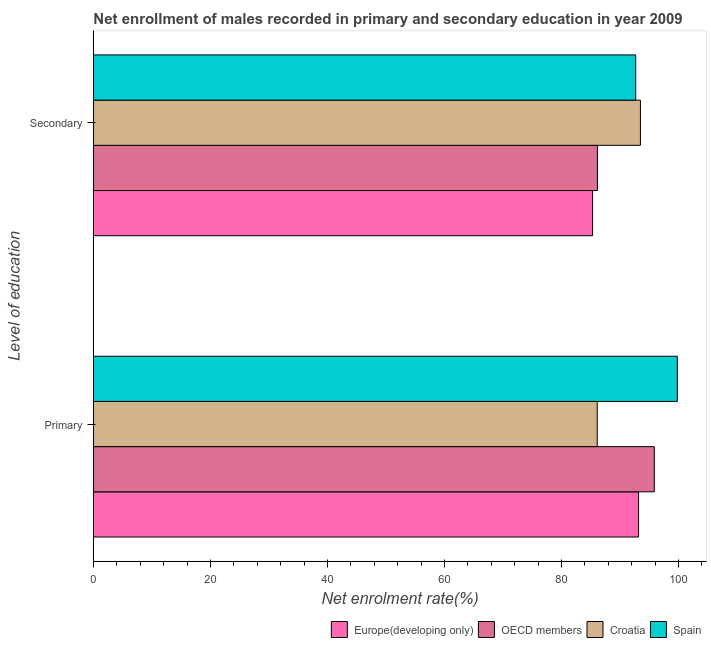How many different coloured bars are there?
Make the answer very short. 4. Are the number of bars per tick equal to the number of legend labels?
Offer a very short reply. Yes. Are the number of bars on each tick of the Y-axis equal?
Provide a succinct answer. Yes. How many bars are there on the 1st tick from the bottom?
Make the answer very short. 4. What is the label of the 1st group of bars from the top?
Give a very brief answer. Secondary. What is the enrollment rate in secondary education in OECD members?
Offer a terse response. 86.14. Across all countries, what is the maximum enrollment rate in primary education?
Ensure brevity in your answer.  99.8. Across all countries, what is the minimum enrollment rate in primary education?
Your answer should be very brief. 86.11. In which country was the enrollment rate in primary education maximum?
Your answer should be compact. Spain. In which country was the enrollment rate in primary education minimum?
Offer a very short reply. Croatia. What is the total enrollment rate in primary education in the graph?
Your response must be concise. 374.94. What is the difference between the enrollment rate in primary education in Spain and that in OECD members?
Give a very brief answer. 3.93. What is the difference between the enrollment rate in primary education in Spain and the enrollment rate in secondary education in Europe(developing only)?
Give a very brief answer. 14.48. What is the average enrollment rate in secondary education per country?
Provide a short and direct response. 89.41. What is the difference between the enrollment rate in secondary education and enrollment rate in primary education in Croatia?
Provide a succinct answer. 7.38. What is the ratio of the enrollment rate in primary education in OECD members to that in Croatia?
Your answer should be very brief. 1.11. Is the enrollment rate in secondary education in Croatia less than that in Europe(developing only)?
Offer a very short reply. No. What does the 4th bar from the bottom in Primary represents?
Your answer should be compact. Spain. How many bars are there?
Your answer should be compact. 8. How many countries are there in the graph?
Your answer should be very brief. 4. Are the values on the major ticks of X-axis written in scientific E-notation?
Keep it short and to the point. No. Does the graph contain grids?
Offer a terse response. No. Where does the legend appear in the graph?
Give a very brief answer. Bottom right. How are the legend labels stacked?
Offer a terse response. Horizontal. What is the title of the graph?
Your response must be concise. Net enrollment of males recorded in primary and secondary education in year 2009. Does "Macao" appear as one of the legend labels in the graph?
Provide a succinct answer. No. What is the label or title of the X-axis?
Your answer should be very brief. Net enrolment rate(%). What is the label or title of the Y-axis?
Make the answer very short. Level of education. What is the Net enrolment rate(%) in Europe(developing only) in Primary?
Ensure brevity in your answer.  93.17. What is the Net enrolment rate(%) in OECD members in Primary?
Make the answer very short. 95.86. What is the Net enrolment rate(%) of Croatia in Primary?
Ensure brevity in your answer.  86.11. What is the Net enrolment rate(%) of Spain in Primary?
Ensure brevity in your answer.  99.8. What is the Net enrolment rate(%) of Europe(developing only) in Secondary?
Offer a terse response. 85.31. What is the Net enrolment rate(%) of OECD members in Secondary?
Make the answer very short. 86.14. What is the Net enrolment rate(%) in Croatia in Secondary?
Offer a terse response. 93.49. What is the Net enrolment rate(%) in Spain in Secondary?
Offer a very short reply. 92.68. Across all Level of education, what is the maximum Net enrolment rate(%) of Europe(developing only)?
Your response must be concise. 93.17. Across all Level of education, what is the maximum Net enrolment rate(%) of OECD members?
Provide a succinct answer. 95.86. Across all Level of education, what is the maximum Net enrolment rate(%) of Croatia?
Make the answer very short. 93.49. Across all Level of education, what is the maximum Net enrolment rate(%) in Spain?
Your response must be concise. 99.8. Across all Level of education, what is the minimum Net enrolment rate(%) of Europe(developing only)?
Provide a short and direct response. 85.31. Across all Level of education, what is the minimum Net enrolment rate(%) in OECD members?
Keep it short and to the point. 86.14. Across all Level of education, what is the minimum Net enrolment rate(%) in Croatia?
Provide a short and direct response. 86.11. Across all Level of education, what is the minimum Net enrolment rate(%) in Spain?
Your answer should be compact. 92.68. What is the total Net enrolment rate(%) of Europe(developing only) in the graph?
Offer a very short reply. 178.49. What is the total Net enrolment rate(%) of OECD members in the graph?
Provide a succinct answer. 182.01. What is the total Net enrolment rate(%) of Croatia in the graph?
Provide a short and direct response. 179.6. What is the total Net enrolment rate(%) in Spain in the graph?
Your answer should be very brief. 192.48. What is the difference between the Net enrolment rate(%) of Europe(developing only) in Primary and that in Secondary?
Make the answer very short. 7.86. What is the difference between the Net enrolment rate(%) in OECD members in Primary and that in Secondary?
Give a very brief answer. 9.72. What is the difference between the Net enrolment rate(%) in Croatia in Primary and that in Secondary?
Provide a succinct answer. -7.38. What is the difference between the Net enrolment rate(%) in Spain in Primary and that in Secondary?
Offer a very short reply. 7.11. What is the difference between the Net enrolment rate(%) of Europe(developing only) in Primary and the Net enrolment rate(%) of OECD members in Secondary?
Offer a terse response. 7.03. What is the difference between the Net enrolment rate(%) of Europe(developing only) in Primary and the Net enrolment rate(%) of Croatia in Secondary?
Your response must be concise. -0.32. What is the difference between the Net enrolment rate(%) of Europe(developing only) in Primary and the Net enrolment rate(%) of Spain in Secondary?
Your answer should be compact. 0.49. What is the difference between the Net enrolment rate(%) in OECD members in Primary and the Net enrolment rate(%) in Croatia in Secondary?
Make the answer very short. 2.37. What is the difference between the Net enrolment rate(%) in OECD members in Primary and the Net enrolment rate(%) in Spain in Secondary?
Make the answer very short. 3.18. What is the difference between the Net enrolment rate(%) in Croatia in Primary and the Net enrolment rate(%) in Spain in Secondary?
Offer a terse response. -6.58. What is the average Net enrolment rate(%) in Europe(developing only) per Level of education?
Provide a succinct answer. 89.24. What is the average Net enrolment rate(%) of OECD members per Level of education?
Make the answer very short. 91. What is the average Net enrolment rate(%) in Croatia per Level of education?
Ensure brevity in your answer.  89.8. What is the average Net enrolment rate(%) in Spain per Level of education?
Your answer should be very brief. 96.24. What is the difference between the Net enrolment rate(%) in Europe(developing only) and Net enrolment rate(%) in OECD members in Primary?
Make the answer very short. -2.69. What is the difference between the Net enrolment rate(%) of Europe(developing only) and Net enrolment rate(%) of Croatia in Primary?
Your answer should be very brief. 7.07. What is the difference between the Net enrolment rate(%) in Europe(developing only) and Net enrolment rate(%) in Spain in Primary?
Make the answer very short. -6.62. What is the difference between the Net enrolment rate(%) of OECD members and Net enrolment rate(%) of Croatia in Primary?
Provide a short and direct response. 9.75. What is the difference between the Net enrolment rate(%) of OECD members and Net enrolment rate(%) of Spain in Primary?
Provide a succinct answer. -3.93. What is the difference between the Net enrolment rate(%) of Croatia and Net enrolment rate(%) of Spain in Primary?
Provide a short and direct response. -13.69. What is the difference between the Net enrolment rate(%) in Europe(developing only) and Net enrolment rate(%) in OECD members in Secondary?
Make the answer very short. -0.83. What is the difference between the Net enrolment rate(%) in Europe(developing only) and Net enrolment rate(%) in Croatia in Secondary?
Give a very brief answer. -8.18. What is the difference between the Net enrolment rate(%) in Europe(developing only) and Net enrolment rate(%) in Spain in Secondary?
Your answer should be very brief. -7.37. What is the difference between the Net enrolment rate(%) of OECD members and Net enrolment rate(%) of Croatia in Secondary?
Your answer should be compact. -7.35. What is the difference between the Net enrolment rate(%) in OECD members and Net enrolment rate(%) in Spain in Secondary?
Your answer should be compact. -6.54. What is the difference between the Net enrolment rate(%) of Croatia and Net enrolment rate(%) of Spain in Secondary?
Ensure brevity in your answer.  0.81. What is the ratio of the Net enrolment rate(%) in Europe(developing only) in Primary to that in Secondary?
Keep it short and to the point. 1.09. What is the ratio of the Net enrolment rate(%) in OECD members in Primary to that in Secondary?
Your answer should be compact. 1.11. What is the ratio of the Net enrolment rate(%) of Croatia in Primary to that in Secondary?
Provide a succinct answer. 0.92. What is the ratio of the Net enrolment rate(%) in Spain in Primary to that in Secondary?
Offer a very short reply. 1.08. What is the difference between the highest and the second highest Net enrolment rate(%) of Europe(developing only)?
Ensure brevity in your answer.  7.86. What is the difference between the highest and the second highest Net enrolment rate(%) of OECD members?
Keep it short and to the point. 9.72. What is the difference between the highest and the second highest Net enrolment rate(%) of Croatia?
Provide a succinct answer. 7.38. What is the difference between the highest and the second highest Net enrolment rate(%) of Spain?
Your response must be concise. 7.11. What is the difference between the highest and the lowest Net enrolment rate(%) in Europe(developing only)?
Your response must be concise. 7.86. What is the difference between the highest and the lowest Net enrolment rate(%) of OECD members?
Provide a succinct answer. 9.72. What is the difference between the highest and the lowest Net enrolment rate(%) in Croatia?
Your response must be concise. 7.38. What is the difference between the highest and the lowest Net enrolment rate(%) of Spain?
Your answer should be very brief. 7.11. 